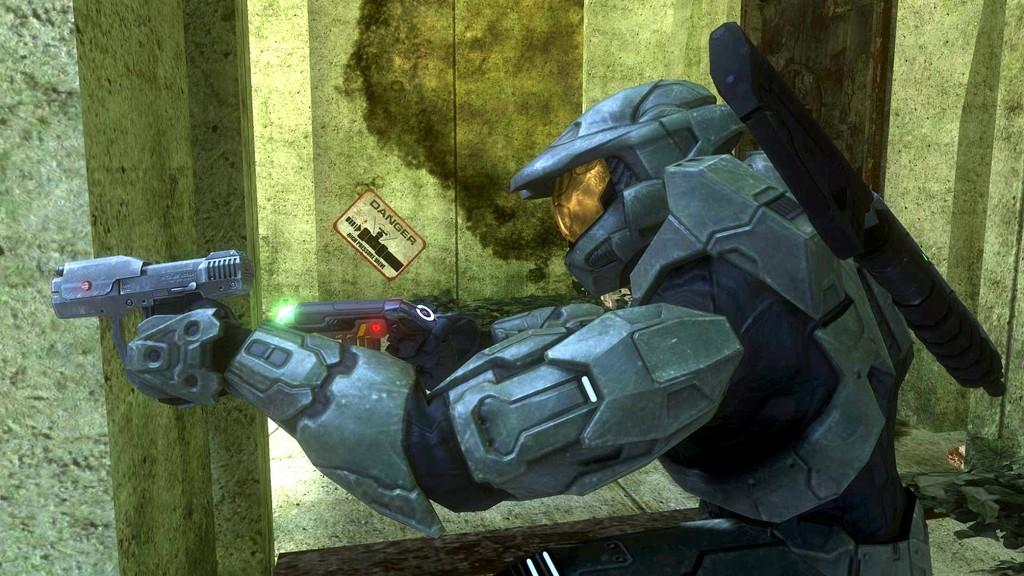What type of character is depicted in the image? The image contains an animated person wearing armor. What is the animated person holding? The person is holding guns. Can you describe the background of the image? There is a sticker attached to the wall in the background of the image. What type of pin can be seen holding the chain on the animated person's armor? There is no chain or pin visible on the animated person's armor in the image. What day of the week is depicted in the image? The image does not depict a specific day of the week. 